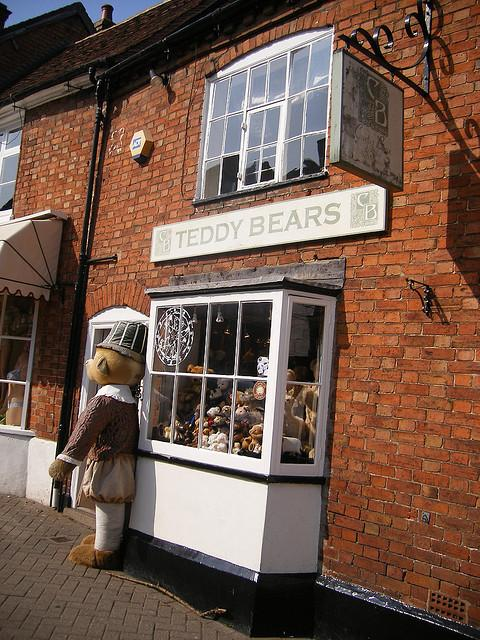What stuffed animal is sold here? teddy bears 